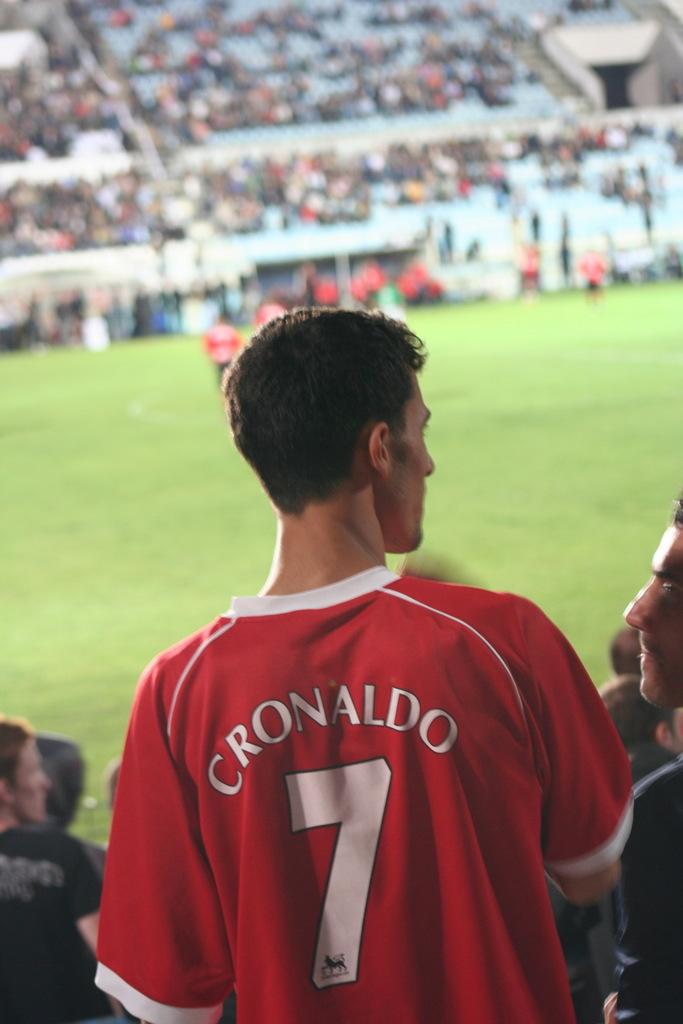What player is the jersey?
Provide a succinct answer. Cronaldo. 